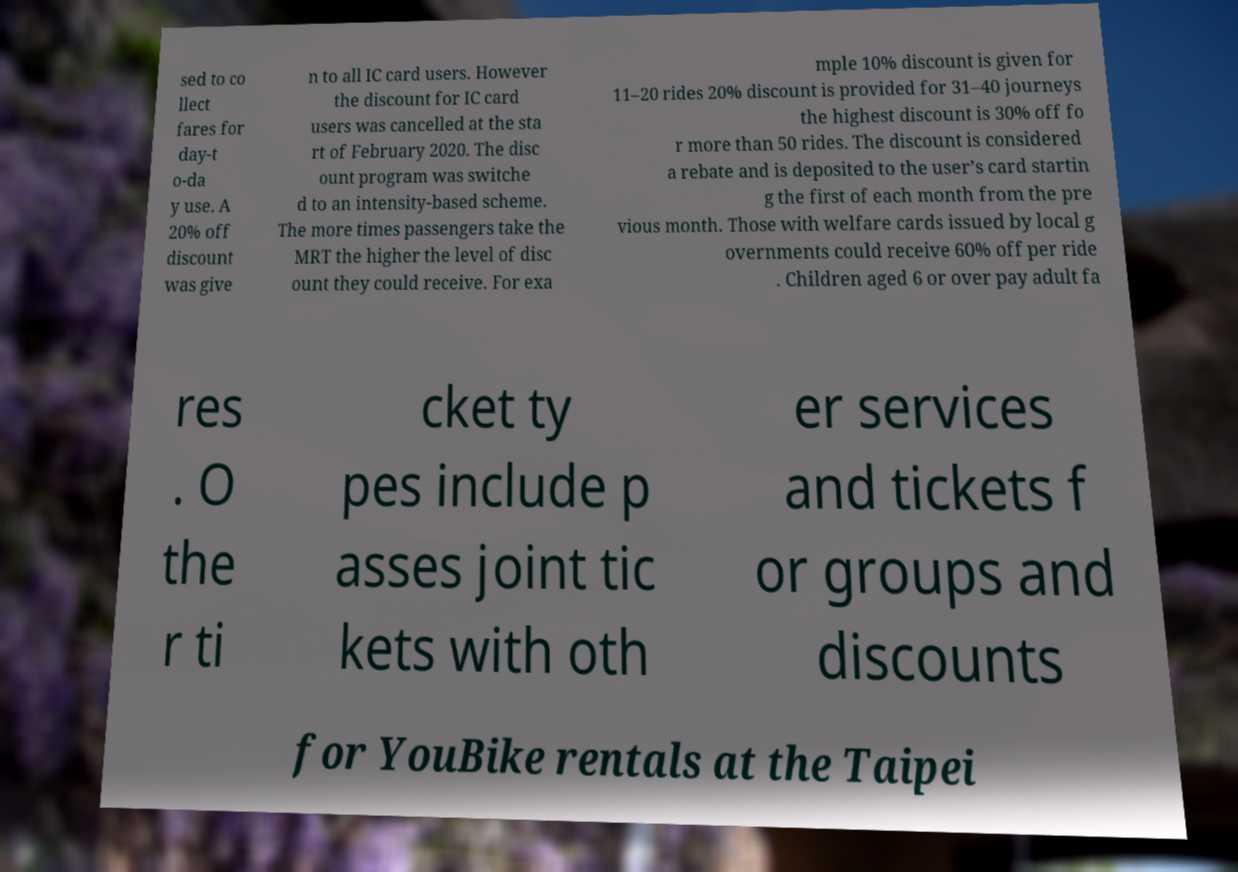Please read and relay the text visible in this image. What does it say? sed to co llect fares for day-t o-da y use. A 20% off discount was give n to all IC card users. However the discount for IC card users was cancelled at the sta rt of February 2020. The disc ount program was switche d to an intensity-based scheme. The more times passengers take the MRT the higher the level of disc ount they could receive. For exa mple 10% discount is given for 11–20 rides 20% discount is provided for 31–40 journeys the highest discount is 30% off fo r more than 50 rides. The discount is considered a rebate and is deposited to the user’s card startin g the first of each month from the pre vious month. Those with welfare cards issued by local g overnments could receive 60% off per ride . Children aged 6 or over pay adult fa res . O the r ti cket ty pes include p asses joint tic kets with oth er services and tickets f or groups and discounts for YouBike rentals at the Taipei 